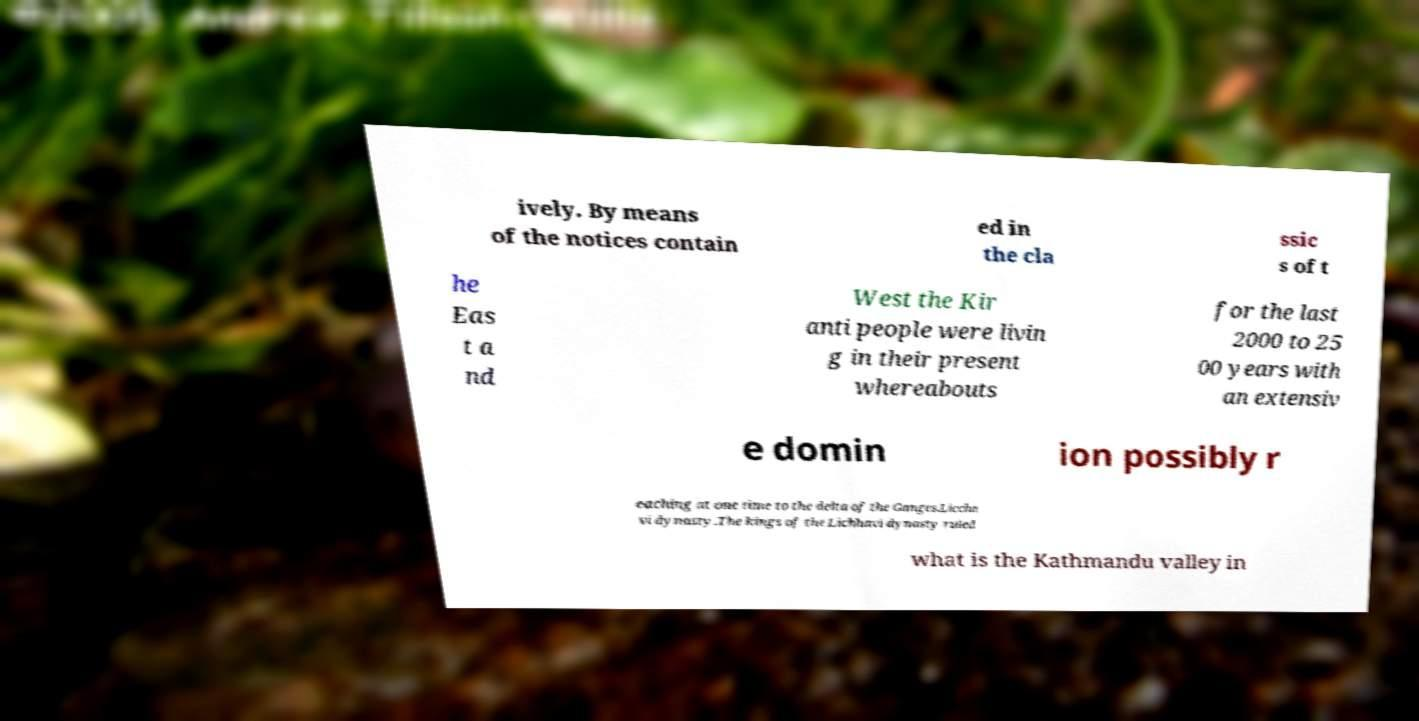Please read and relay the text visible in this image. What does it say? ively. By means of the notices contain ed in the cla ssic s of t he Eas t a nd West the Kir anti people were livin g in their present whereabouts for the last 2000 to 25 00 years with an extensiv e domin ion possibly r eaching at one time to the delta of the Ganges.Liccha vi dynasty.The kings of the Lichhavi dynasty ruled what is the Kathmandu valley in 